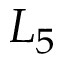<formula> <loc_0><loc_0><loc_500><loc_500>L _ { 5 }</formula> 